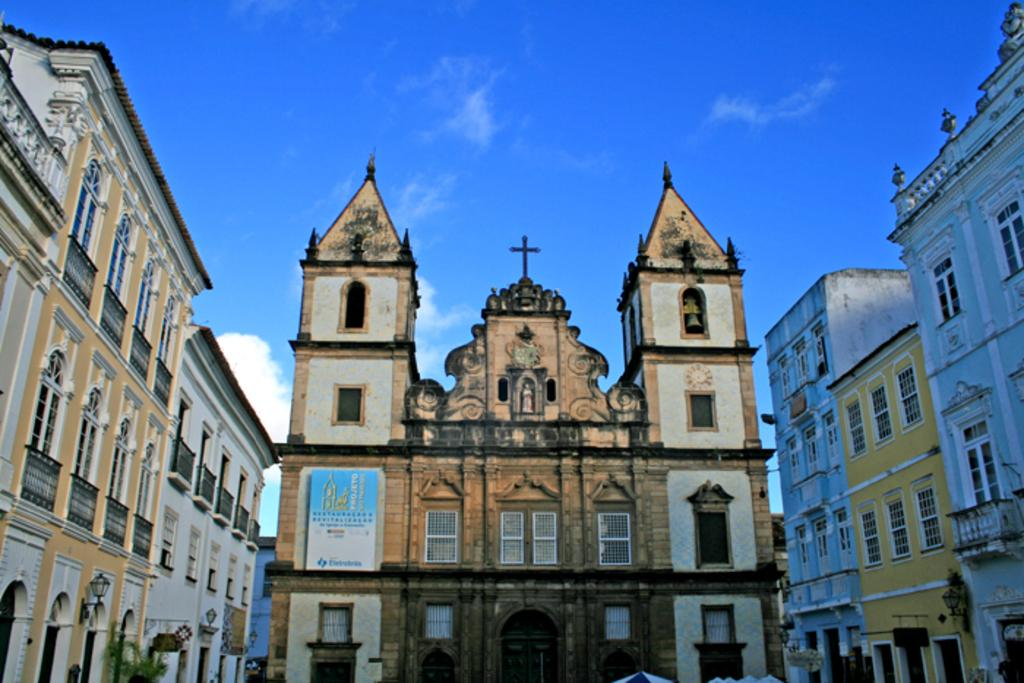What type of structures can be seen in the image? There are buildings in the image. What can be seen in the background of the image? The sky is visible in the background of the image. Where is the tree located in the image? There is a tree on the left side of the image. What is the price of the park shown in the image? There is no park present in the image, so it is not possible to determine the price. 